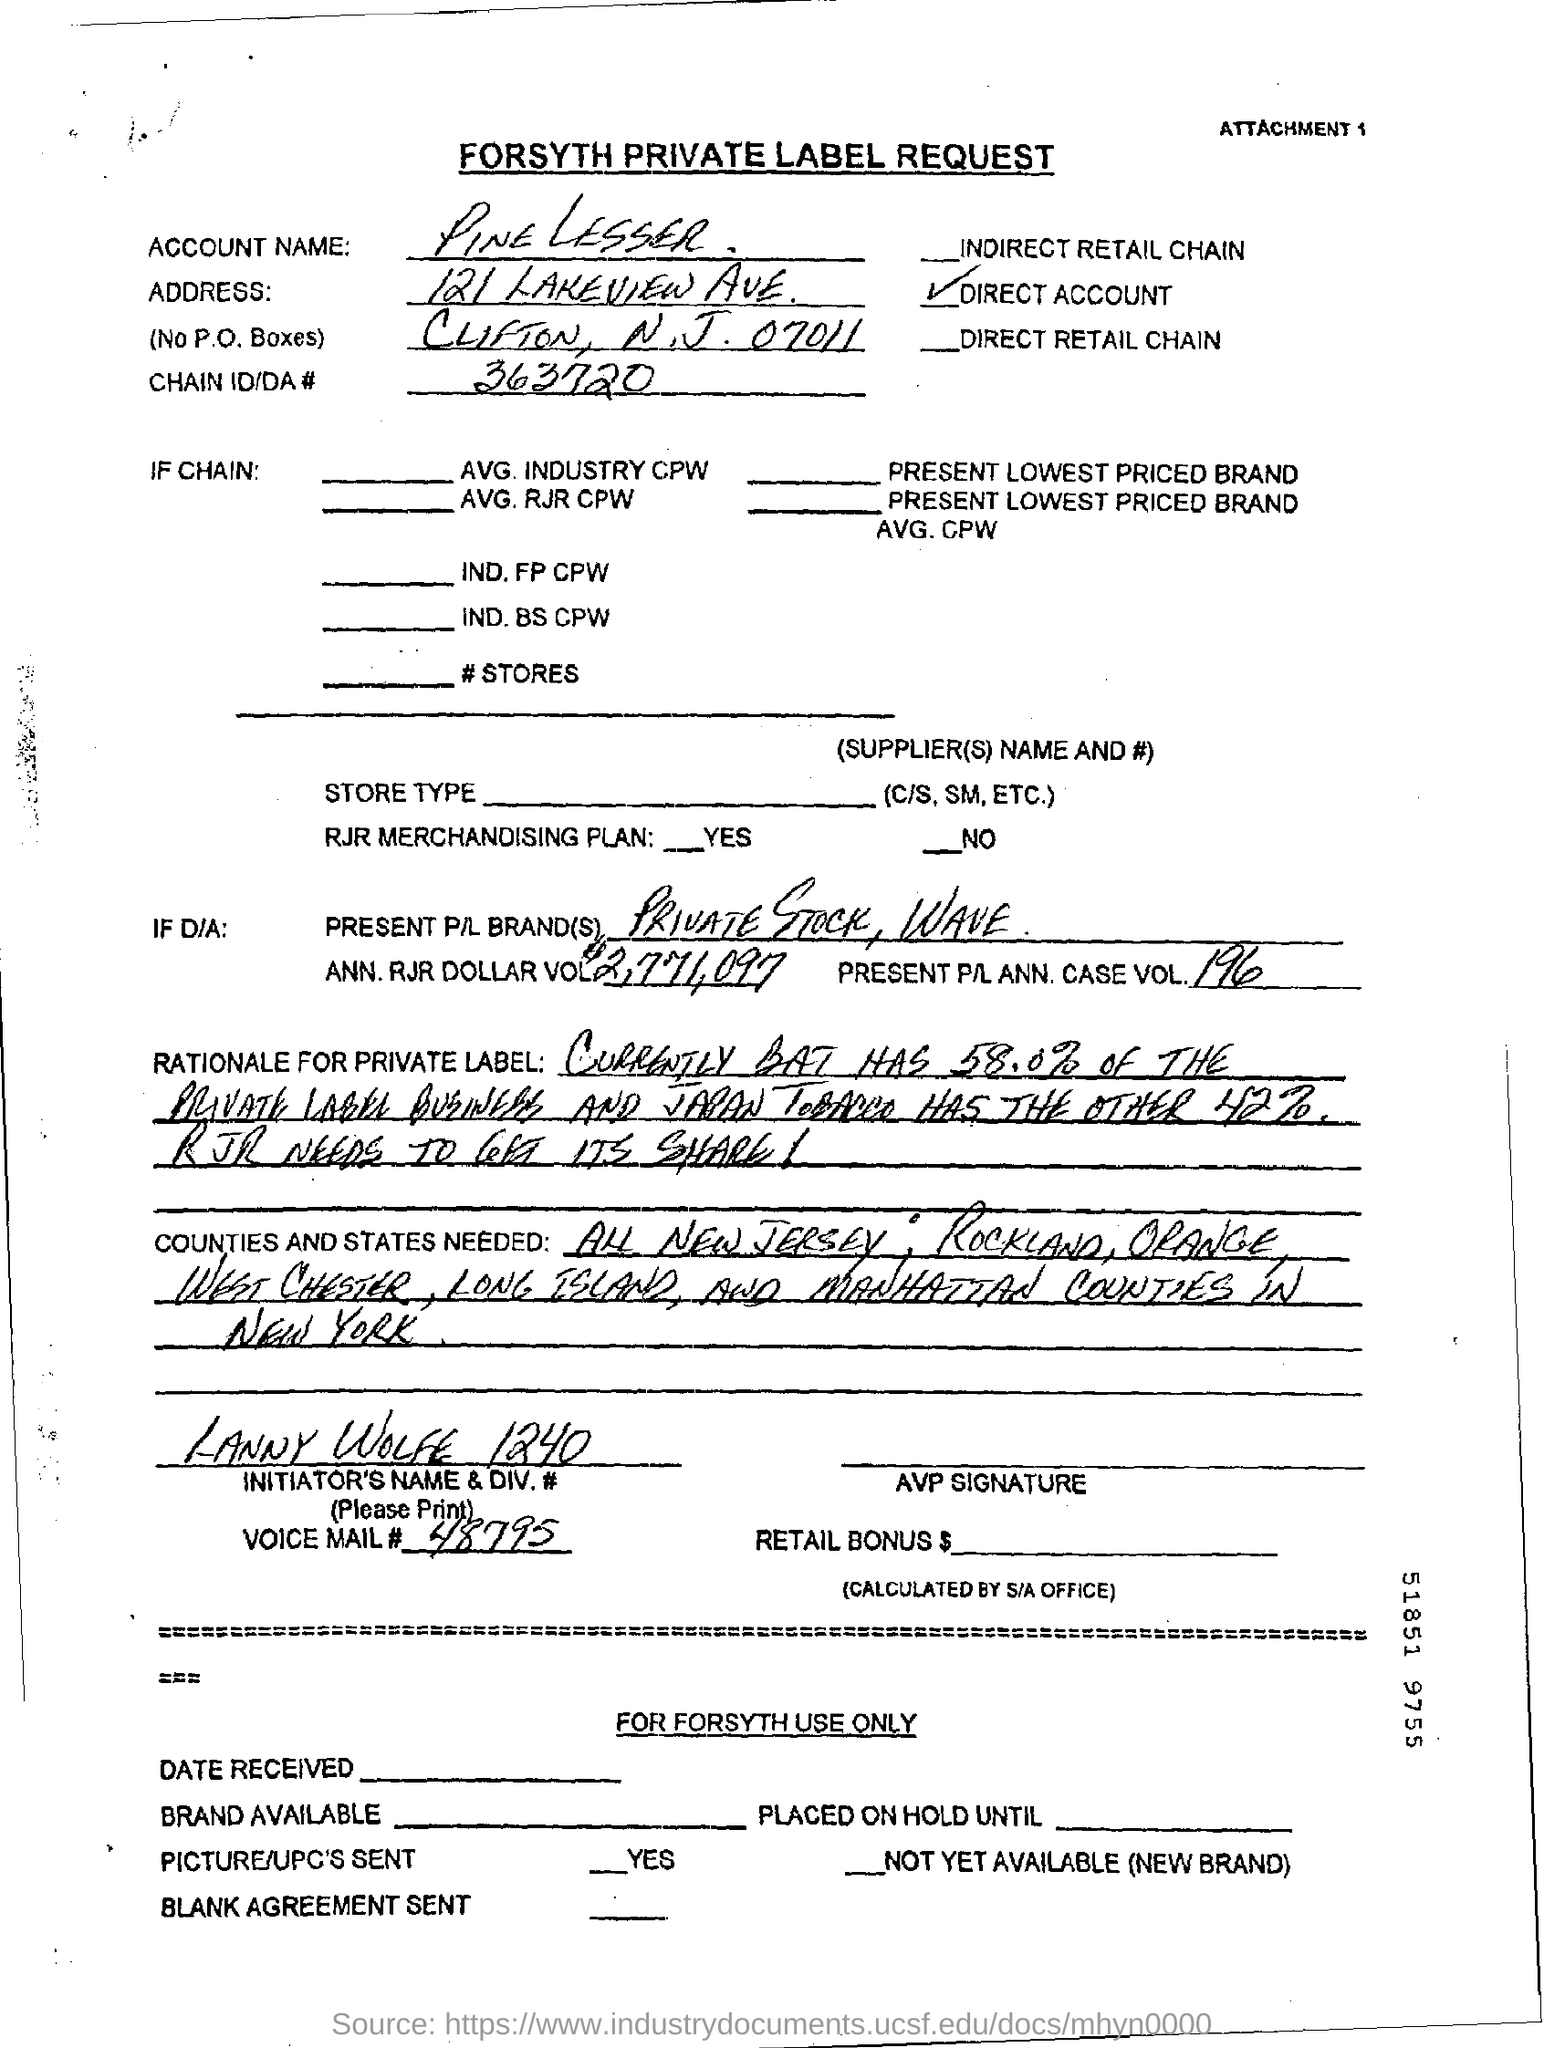Point out several critical features in this image. The account name provided in the form is Pine Lesser. The chain ID/DA no given in the form is 363720... The voice mail number mentioned in the form is 48795. 